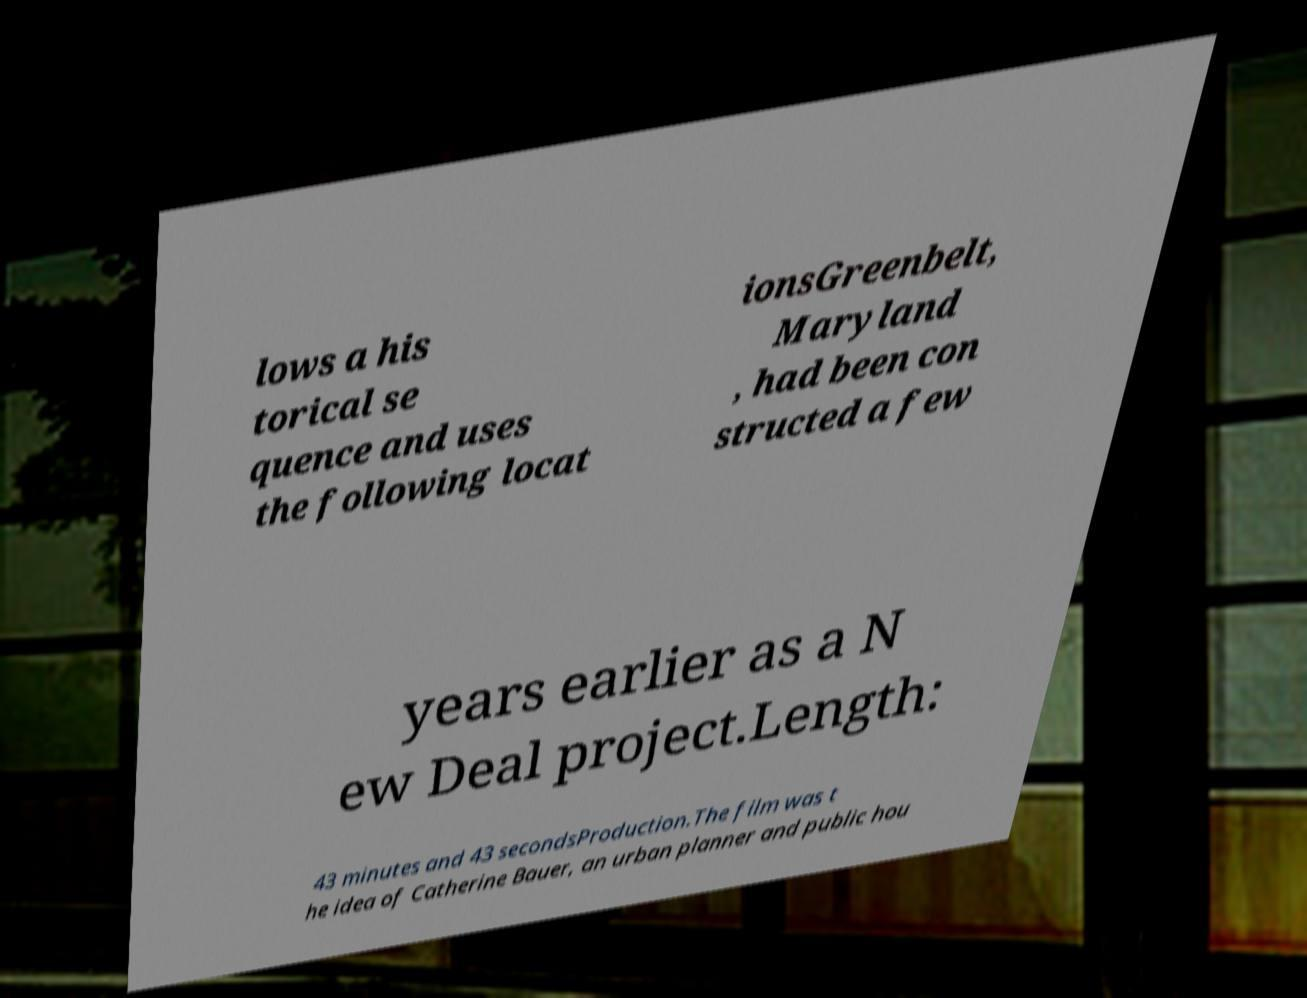For documentation purposes, I need the text within this image transcribed. Could you provide that? lows a his torical se quence and uses the following locat ionsGreenbelt, Maryland , had been con structed a few years earlier as a N ew Deal project.Length: 43 minutes and 43 secondsProduction.The film was t he idea of Catherine Bauer, an urban planner and public hou 